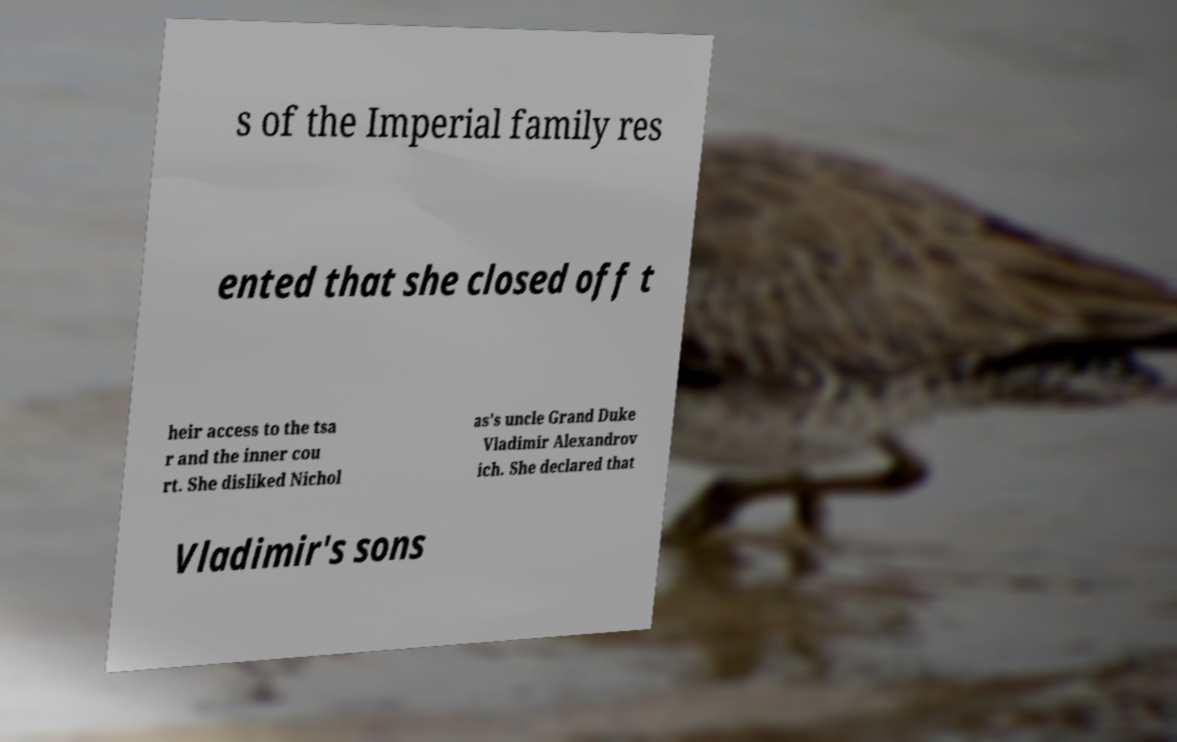Could you assist in decoding the text presented in this image and type it out clearly? s of the Imperial family res ented that she closed off t heir access to the tsa r and the inner cou rt. She disliked Nichol as's uncle Grand Duke Vladimir Alexandrov ich. She declared that Vladimir's sons 